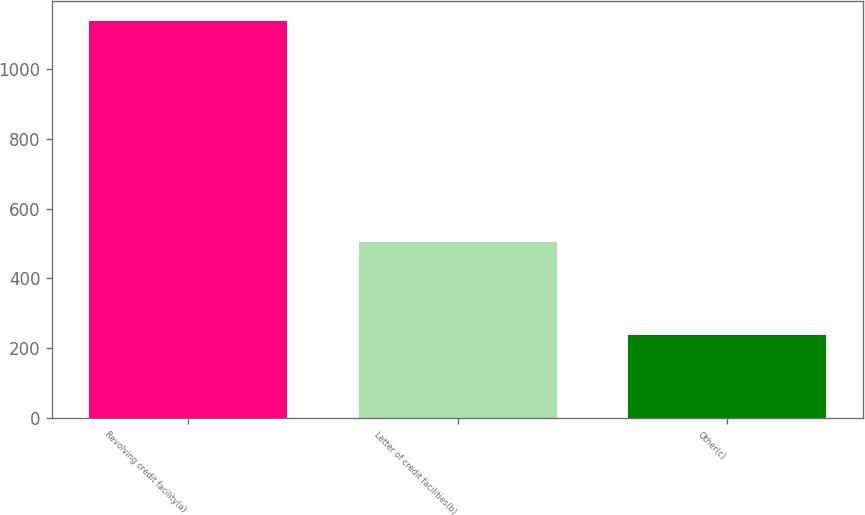Convert chart. <chart><loc_0><loc_0><loc_500><loc_500><bar_chart><fcel>Revolving credit facility(a)<fcel>Letter of credit facilities(b)<fcel>Other(c)<nl><fcel>1138<fcel>505<fcel>237<nl></chart> 